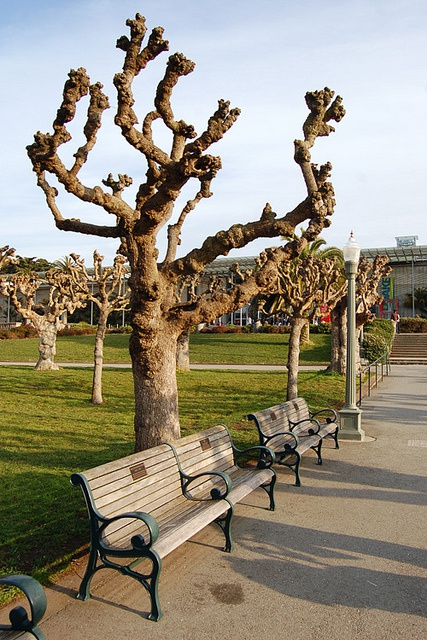Describe the objects in this image and their specific colors. I can see bench in lightblue, black, and tan tones, bench in lightblue, black, gray, darkgray, and tan tones, and bench in lightblue, black, gray, and purple tones in this image. 